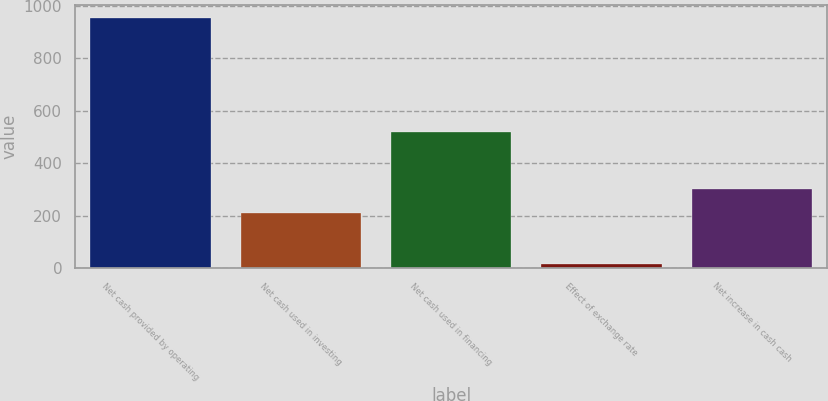Convert chart. <chart><loc_0><loc_0><loc_500><loc_500><bar_chart><fcel>Net cash provided by operating<fcel>Net cash used in investing<fcel>Net cash used in financing<fcel>Effect of exchange rate<fcel>Net increase in cash cash<nl><fcel>952.6<fcel>208.1<fcel>518.4<fcel>16.4<fcel>301.72<nl></chart> 